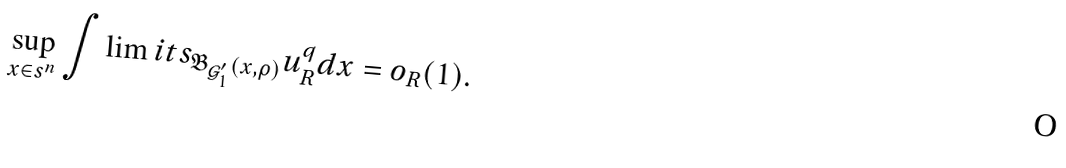Convert formula to latex. <formula><loc_0><loc_0><loc_500><loc_500>\sup _ { x \in \real s ^ { n } } \int \lim i t s _ { \mathfrak B _ { \mathcal { G } ^ { \prime } _ { 1 } } ( x , \rho ) } u _ { R } ^ { q } d x = o _ { R } ( 1 ) .</formula> 